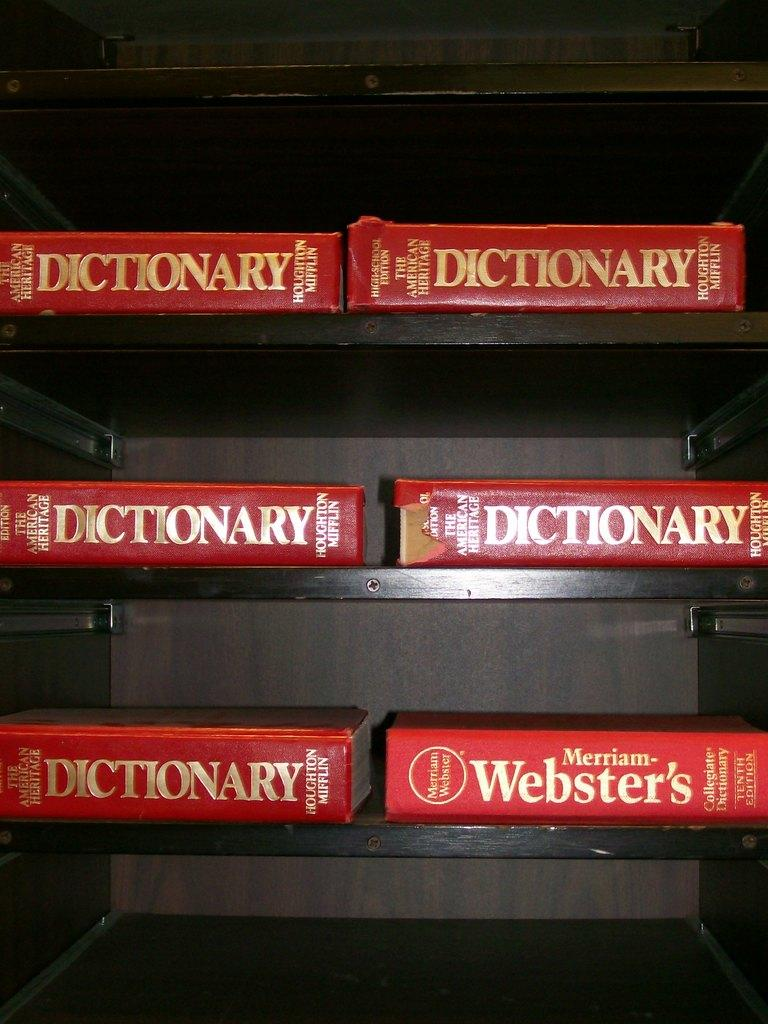<image>
Provide a brief description of the given image. Five American Heritage and one Webster's dictionary are laying on shelves. 